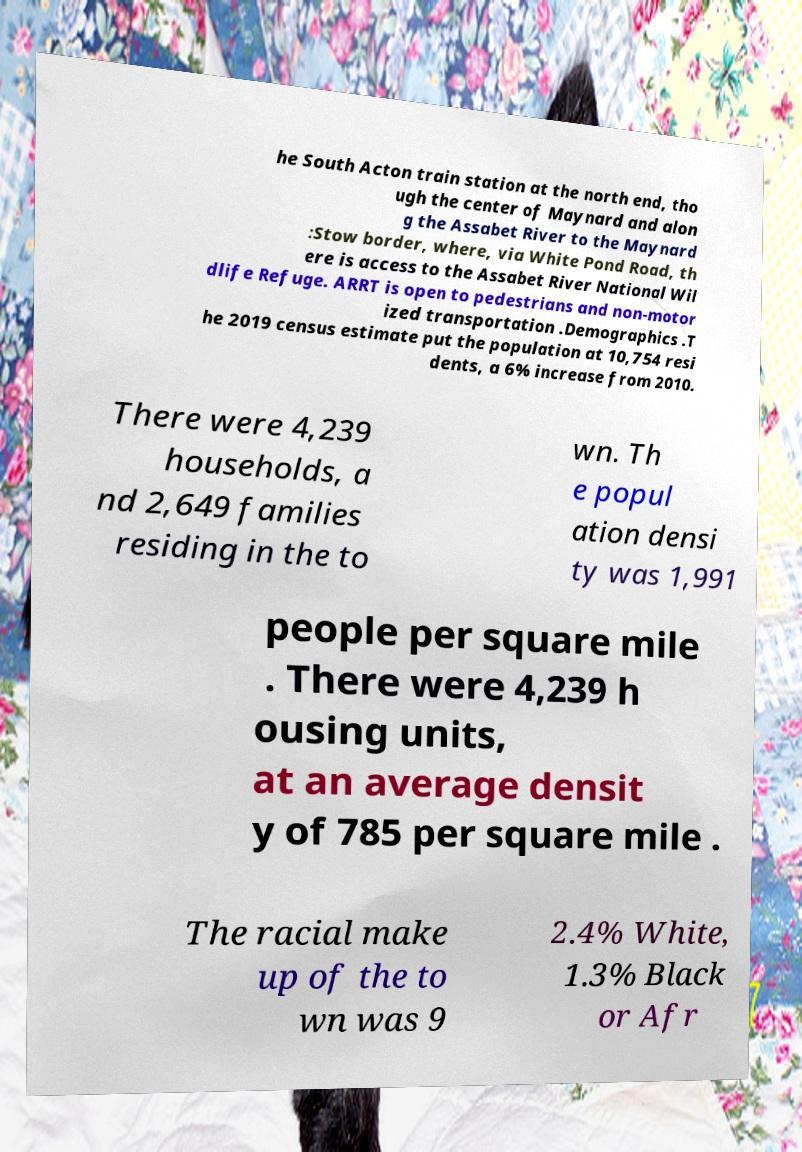Can you read and provide the text displayed in the image?This photo seems to have some interesting text. Can you extract and type it out for me? he South Acton train station at the north end, tho ugh the center of Maynard and alon g the Assabet River to the Maynard :Stow border, where, via White Pond Road, th ere is access to the Assabet River National Wil dlife Refuge. ARRT is open to pedestrians and non-motor ized transportation .Demographics .T he 2019 census estimate put the population at 10,754 resi dents, a 6% increase from 2010. There were 4,239 households, a nd 2,649 families residing in the to wn. Th e popul ation densi ty was 1,991 people per square mile . There were 4,239 h ousing units, at an average densit y of 785 per square mile . The racial make up of the to wn was 9 2.4% White, 1.3% Black or Afr 